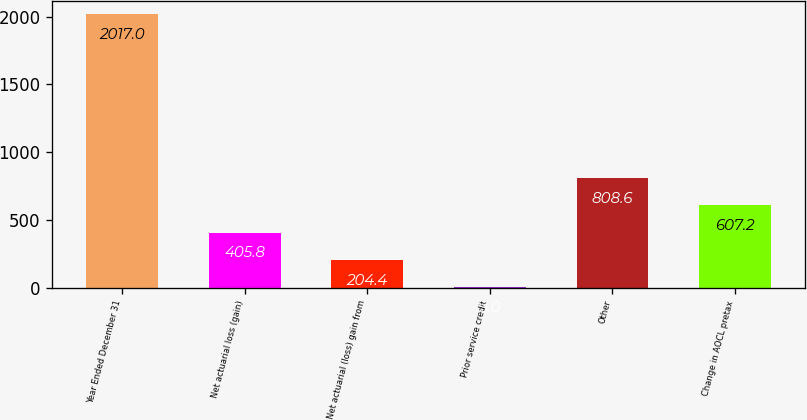<chart> <loc_0><loc_0><loc_500><loc_500><bar_chart><fcel>Year Ended December 31<fcel>Net actuarial loss (gain)<fcel>Net actuarial (loss) gain from<fcel>Prior service credit<fcel>Other<fcel>Change in AOCL pretax<nl><fcel>2017<fcel>405.8<fcel>204.4<fcel>3<fcel>808.6<fcel>607.2<nl></chart> 